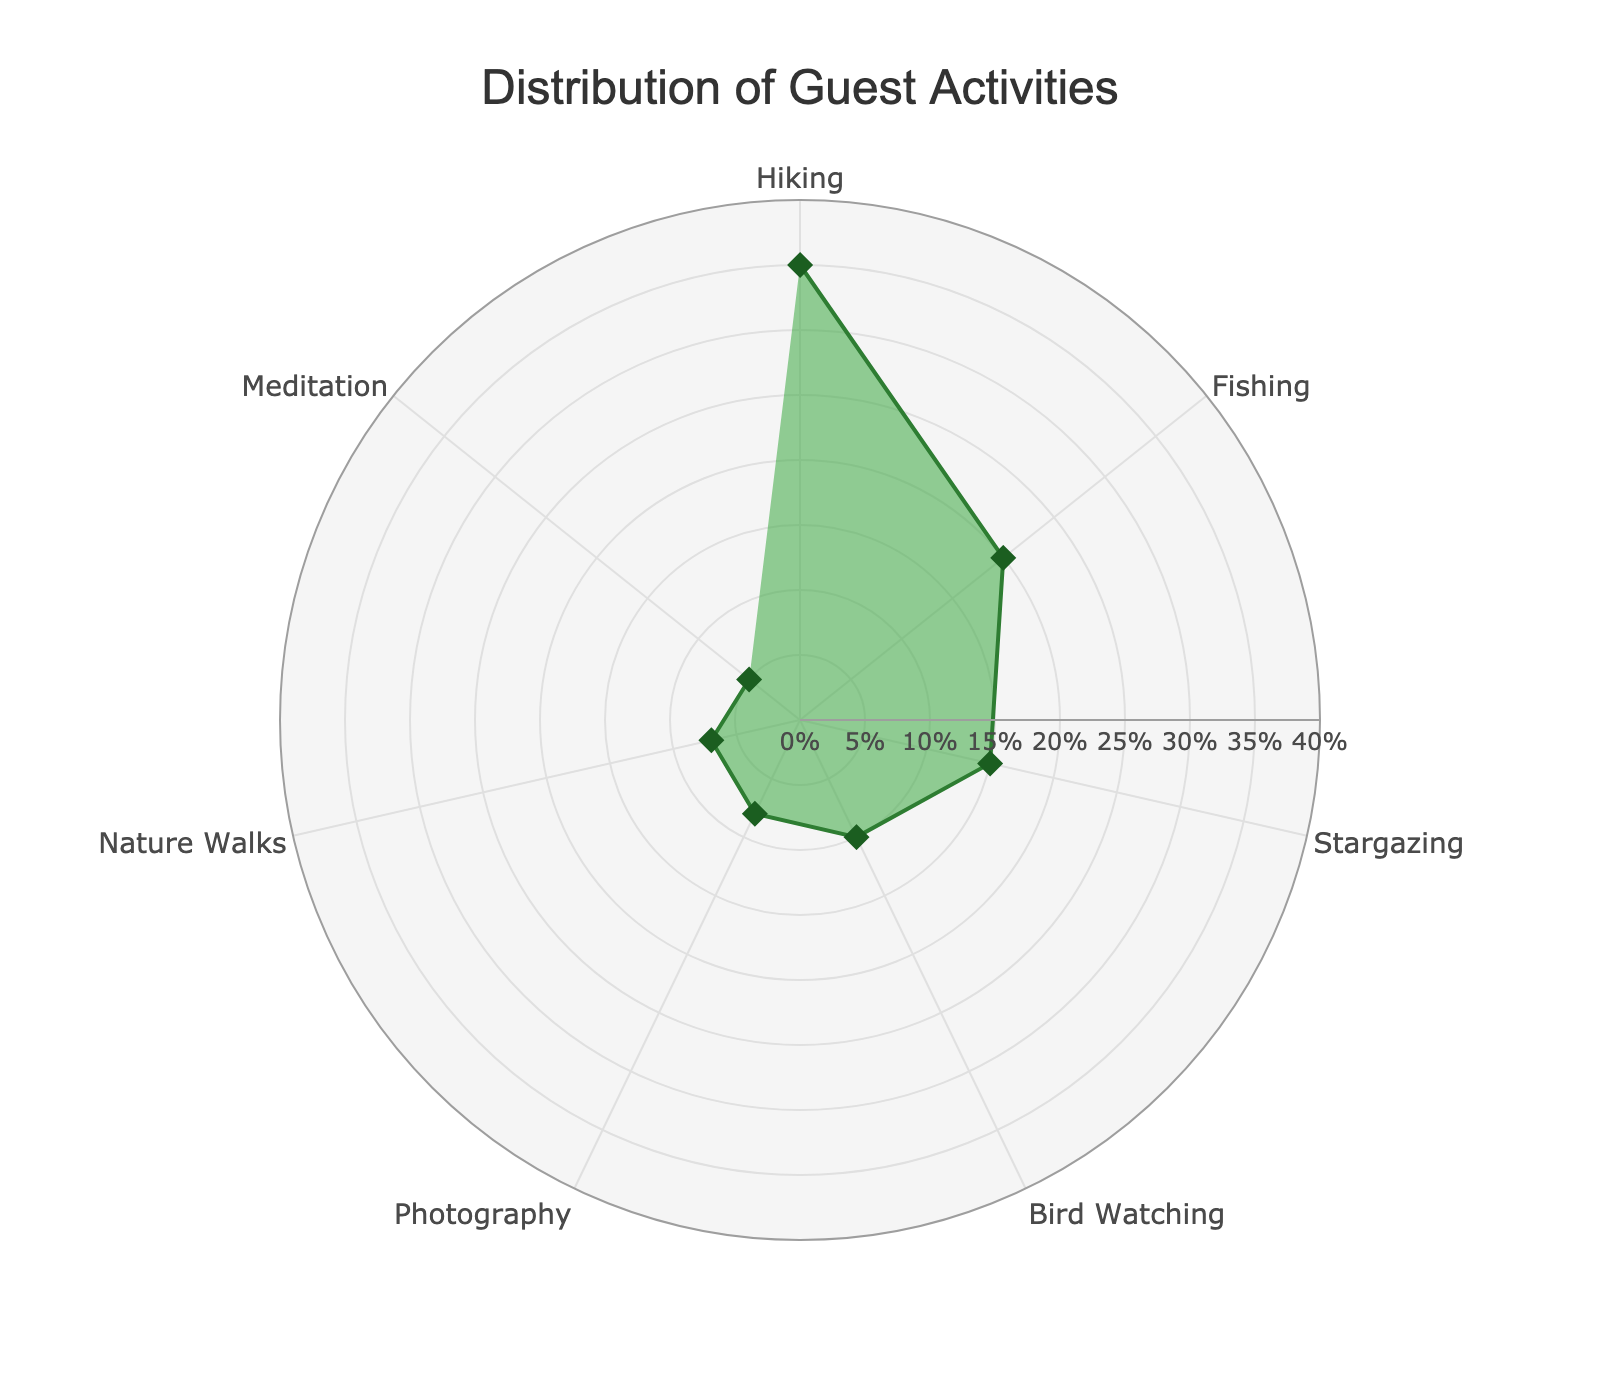How many activities are listed in the polar chart? The polar chart includes all arcs representing different activities. Counting them gives us the total number of activities.
Answer: 7 Which activity has the highest percentage of participation? By examining the radial axis values attached to each activity, we see that Hiking has the longest arc, marked with the highest percentage value.
Answer: Hiking What is the sum of the percentages for Fishing and Stargazing? From the chart, Fishing has a value of 20% and Stargazing has a value of 15%. Adding them together gives 20% + 15% = 35%.
Answer: 35% Is Bird Watching more or less popular than Photography? Comparing the lengths of the arcs for Bird Watching and Photography, Bird Watching has a percentage of 10% while Photography has a percentage of 8%. 10% > 8%, thus Bird Watching is more popular.
Answer: More What percentage of guests partake in Meditation activities? Locating the Meditation segment, the percentage value associated with it is readily read off the axis, which is 5%.
Answer: 5% How much greater is the percentage of guests who go Hiking compared to those who engage in Nature Walks? Hiking has a percentage of 35% while Nature Walks have 7%. Subtracting 7% from 35% gives us 35% - 7% = 28%.
Answer: 28% What is the average percentage for all activities? The percentages are 35, 20, 15, 10, 8, 7, and 5. Summing these values gives 35 + 20 + 15 + 10 + 8 + 7 + 5 = 100. Dividing by the total number 7 gives 100/7 ≈ 14.29%.
Answer: 14.29% Which is more popular, Hiking or the combined total of Bird Watching and Fishing? Hiking is 35%, while Bird Watching and Fishing combined is 10% + 20% = 30%. 35% > 30%, so Hiking is more popular.
Answer: Hiking What is the combined percentage for activities related to observing nature (Bird Watching and Photography)? Bird Watching has 10%, and Photography has 8%. Adding them together gives 10% + 8% = 18%.
Answer: 18% By how much does the percentage of Stargazing exceed Meditation? Stargazing has a percentage of 15 while Meditation is at 5. Subtracting the Meditation percentage from Stargazing gives us 15% - 5% = 10%.
Answer: 10% 